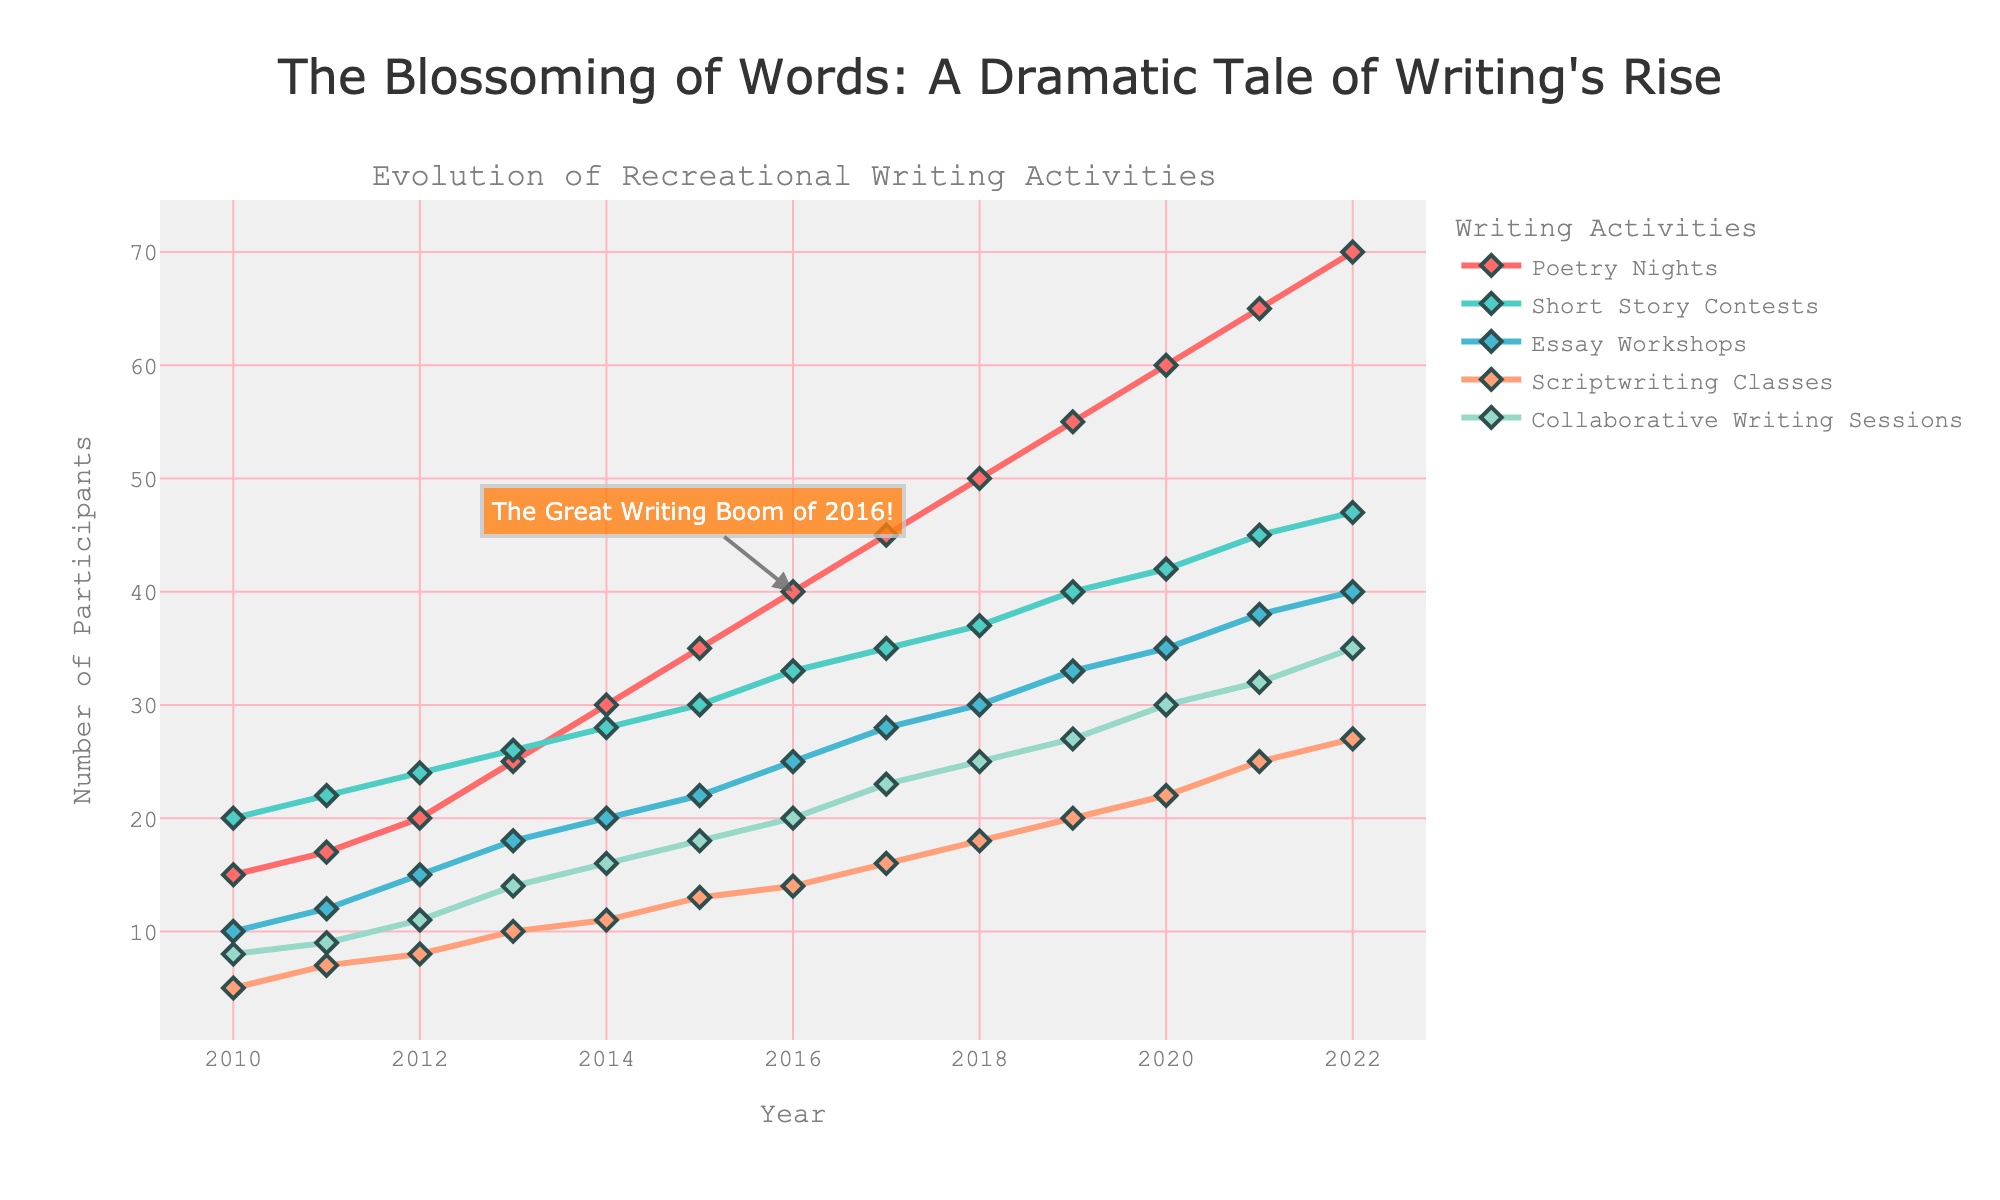What is the overall trend in the popularity of Poetry Nights between 2010 and 2022? The figure shows that the number of participants in Poetry Nights increased each year from 15 in 2010 to 70 in 2022. This indicates a strong upward trend over the 12-year period.
Answer: Increasing trend How many activities reached 40 participants by the year 2019? Observing the figure for the year 2019, Poetry Nights, Short Story Contests, and Collaborative Writing Sessions all have participants above 40. Specifically, Poetry Nights had 55, Short Story Contests had 40, Collaborative Writing Sessions had 27, while the other activities had lower numbers.
Answer: 2 activities (Poetry Nights, Short Story Contests) Which writing activity had the highest number of participants in 2021, and how many participants were there? Looking at the year 2021, Poetry Nights had the highest number of participants with 65 participants.
Answer: Poetry Nights with 65 participants By how many participants did Scriptwriting Classes increase from 2015 to 2020? In 2015 there were 13 participants in Scriptwriting Classes, and in 2020 there were 22 participants. To find the increase: 22 - 13 = 9.
Answer: 9 participants What is the difference in participant growth between Essay Workshops and Collaborative Writing Sessions from 2010 to 2022? The figure shows Essay Workshops had 10 participants in 2010 and 40 in 2022. Collaborative Writing Sessions had 8 participants in 2010 and 35 in 2022. The growth differences are: (40-10) for Essay Workshops = 30, and (35-8) for Collaborative Writing Sessions = 27. The difference in growth is 30 - 27 = 3.
Answer: 3 participants During which year did the number of participants in Short Story Contests reach 30? According to the plot, the number of participants in Short Story Contests reached 30 in the year 2015.
Answer: 2015 What is the average number of participants in Scriptwriting Classes from 2010 to 2015? The number of participants in Scriptwriting Classes from 2010 to 2015 is {5, 7, 8, 10, 11, 13}. The sum is 54, and there are 6 years. So, the average is 54 / 6 = 9.
Answer: 9 participants Which writing activity saw the biggest increase in participants between 2016 and 2018? From the figure, between 2016 and 2018: Poetry Nights increased from 40 to 50, Short Story Contests from 33 to 37, Essay Workshops from 25 to 30, Scriptwriting Classes from 14 to 18, and Collaborative Writing Sessions from 20 to 25. Poetry Nights saw the largest increase, with 10 additional participants.
Answer: Poetry Nights When did Poetry Nights surpass 50 participants? Observing the plot, Poetry Nights reached 50 participants in the year 2018.
Answer: 2018 What is the total number of participants in all activities in the year 2020? In 2020, the participants were Poetry Nights (60), Short Story Contests (42), Essay Workshops (35), Scriptwriting Classes (22), and Collaborative Writing Sessions (30). The total is 60 + 42 + 35 + 22 + 30 = 189.
Answer: 189 participants 